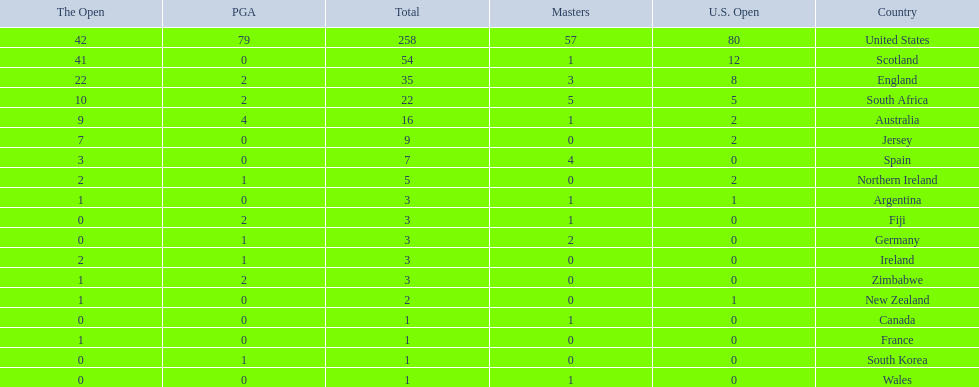What are all the countries? United States, Scotland, England, South Africa, Australia, Jersey, Spain, Northern Ireland, Argentina, Fiji, Germany, Ireland, Zimbabwe, New Zealand, Canada, France, South Korea, Wales. Which ones are located in africa? South Africa, Zimbabwe. Of those, which has the least champion golfers? Zimbabwe. 